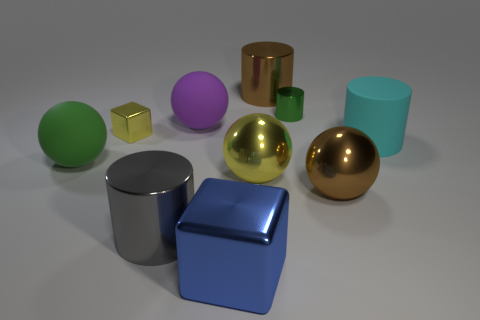There is a block that is to the left of the blue block; is it the same size as the tiny green metallic cylinder?
Provide a short and direct response. Yes. What number of green things are big cylinders or small things?
Offer a terse response. 1. What is the cube that is on the left side of the big purple rubber thing made of?
Provide a succinct answer. Metal. There is a large brown object in front of the big green rubber ball; what number of small yellow blocks are in front of it?
Ensure brevity in your answer.  0. How many large blue metallic things are the same shape as the green metallic object?
Provide a succinct answer. 0. How many big brown things are there?
Provide a short and direct response. 2. The metallic cylinder that is in front of the big green sphere is what color?
Keep it short and to the point. Gray. What color is the large ball that is left of the big shiny thing to the left of the large blue object?
Your answer should be very brief. Green. What color is the thing that is the same size as the yellow metallic cube?
Provide a succinct answer. Green. What number of big objects are both behind the big yellow shiny thing and in front of the green cylinder?
Make the answer very short. 3. 